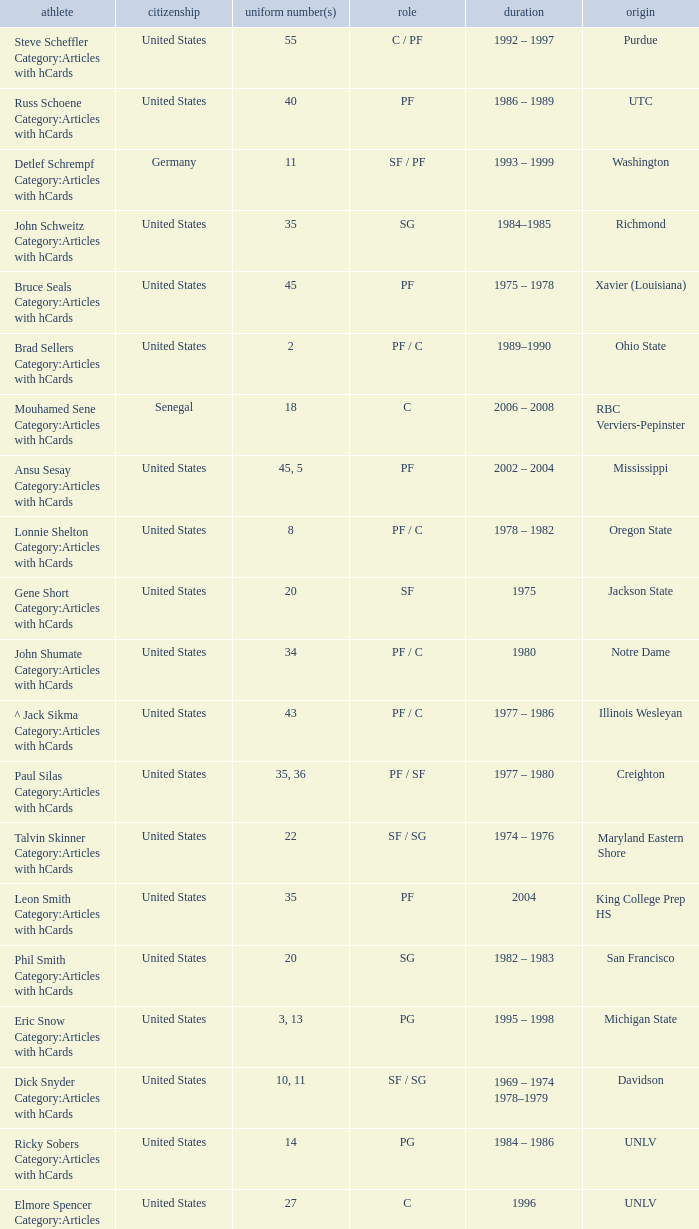What nationality is the player from Oregon State? United States. 